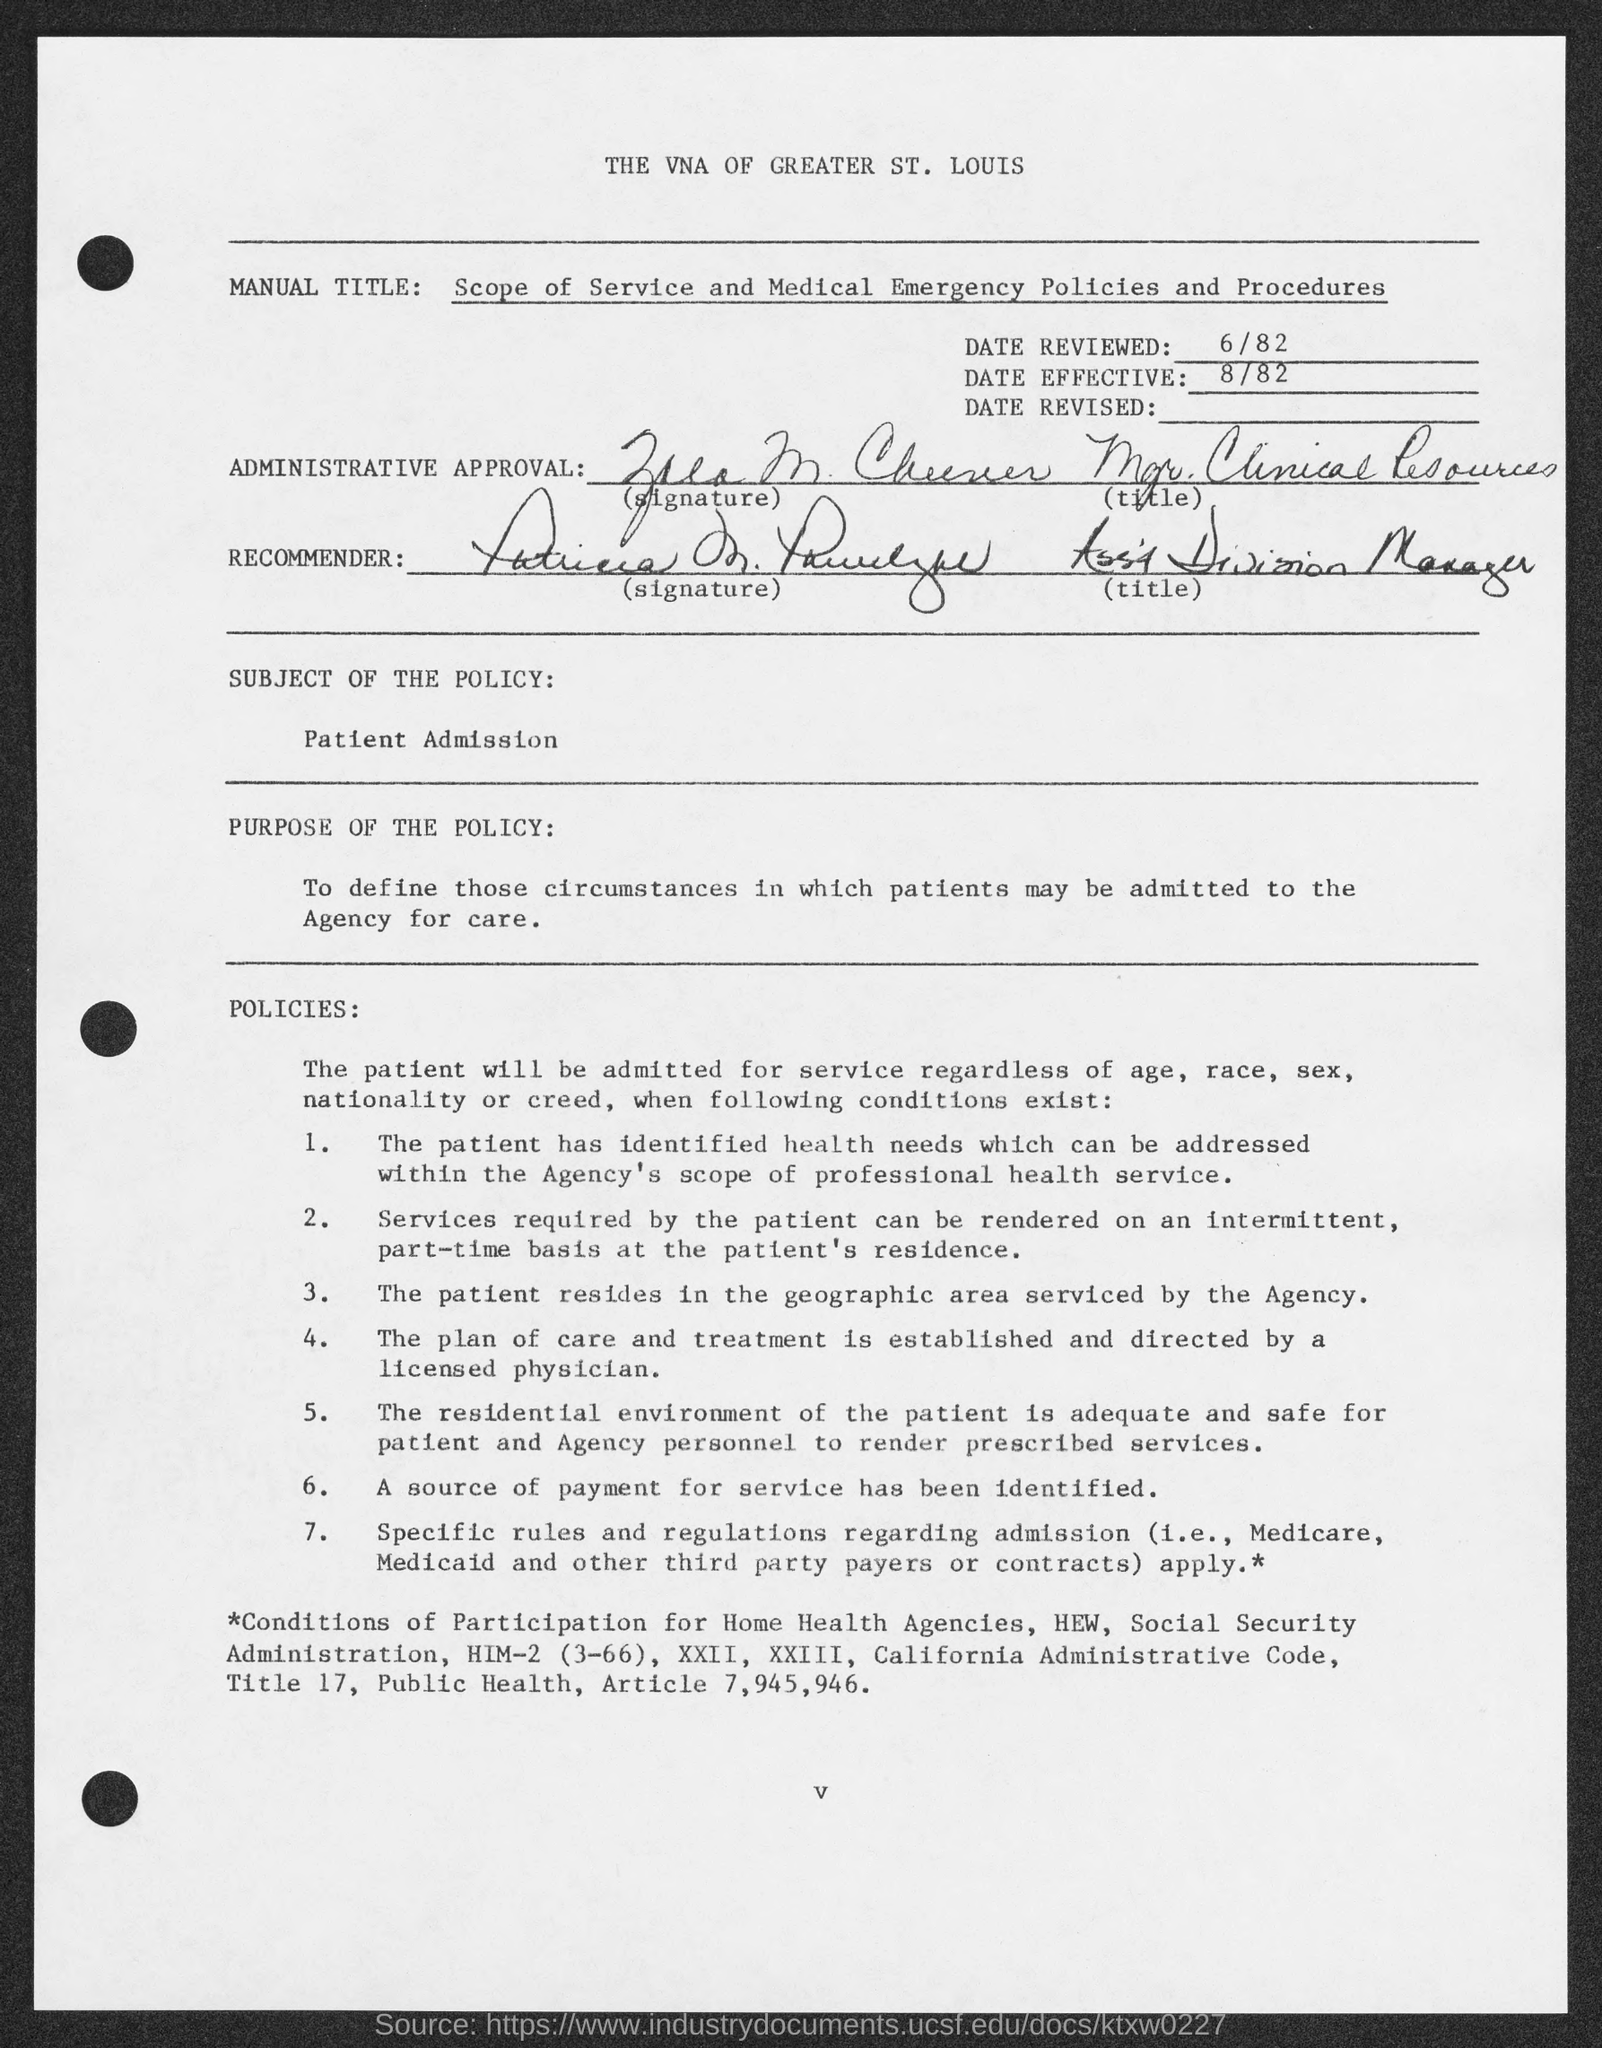What is the date reviewed mentioned in the document?
Your answer should be very brief. 6/82. What is the manual title given in the document?
Your response must be concise. Scope of Service and Medical Emergency Policies and Procedures. What is the subject of the policy as per the document?
Offer a very short reply. Patient Admission. What is the date effective given in the document?
Your response must be concise. 8/82. What is the purpose of the policy as per the document?
Your answer should be compact. To define those circumstances in which patients may be admitted to the Agency for care. 